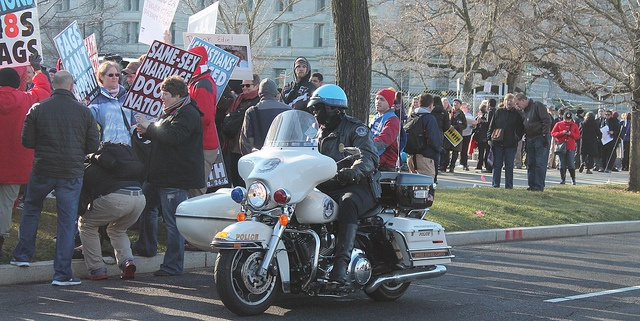Describe the objects in this image and their specific colors. I can see motorcycle in lightblue, black, gray, and darkgray tones, people in lightblue, black, gray, and darkgray tones, people in lightblue, black, gray, and darkblue tones, people in lightblue, black, gray, and darkblue tones, and people in lightblue, black, gray, and darkblue tones in this image. 